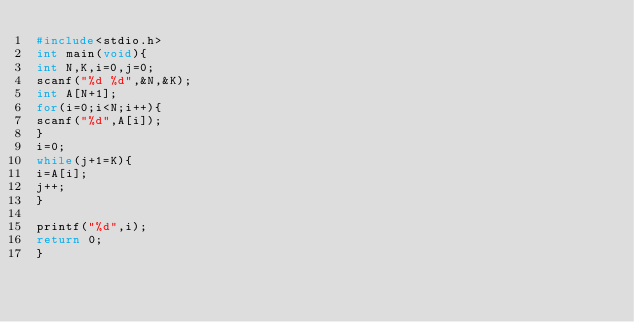Convert code to text. <code><loc_0><loc_0><loc_500><loc_500><_C_>#include<stdio.h>
int main(void){
int N,K,i=0,j=0;
scanf("%d %d",&N,&K);
int A[N+1];
for(i=0;i<N;i++){
scanf("%d",A[i]);
}
i=0;
while(j+1=K){
i=A[i];
j++;
}

printf("%d",i);
return 0;
}</code> 